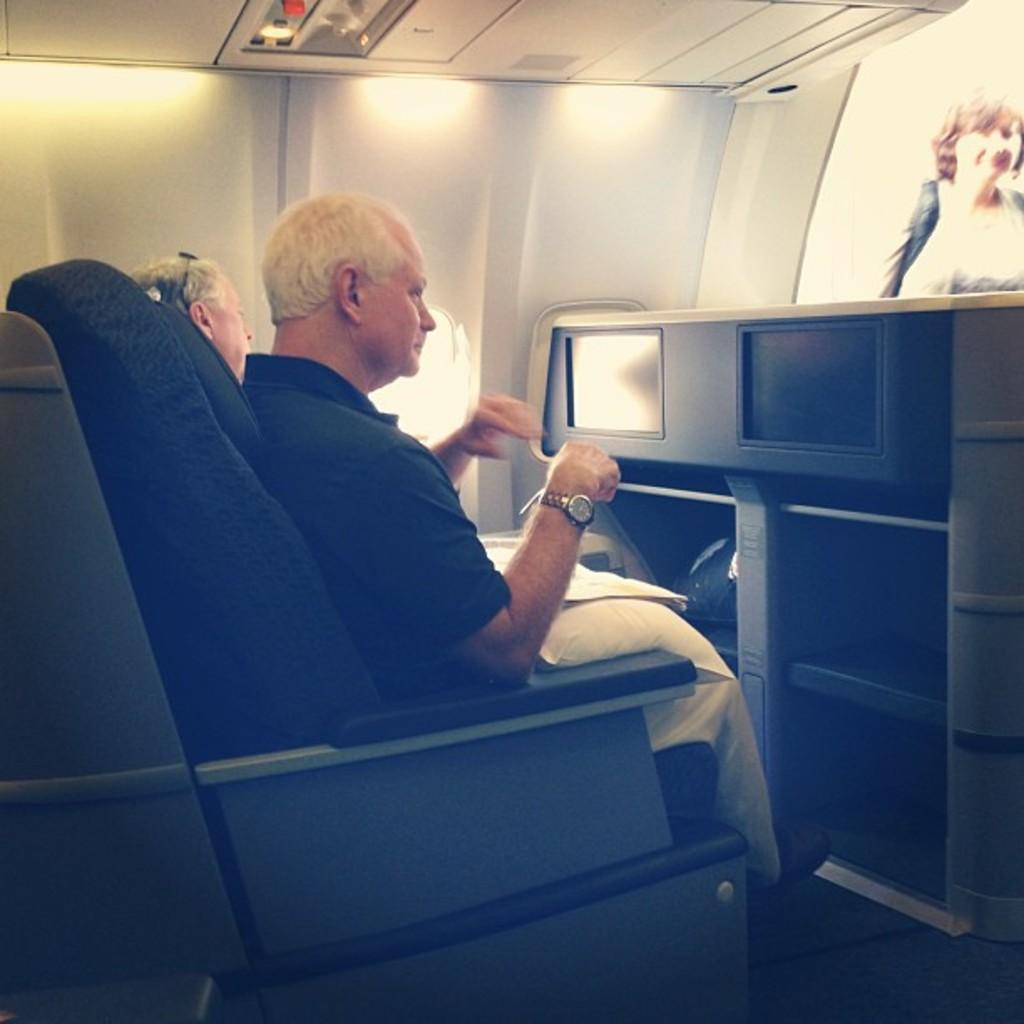Describe this image in one or two sentences. In this image we can see two persons. One person is wearing a watch. They are sitting. In front of them there is a cupboard with racks. Near to the cupboard there is a screen. In the back there is a wall. Also there are lights. 